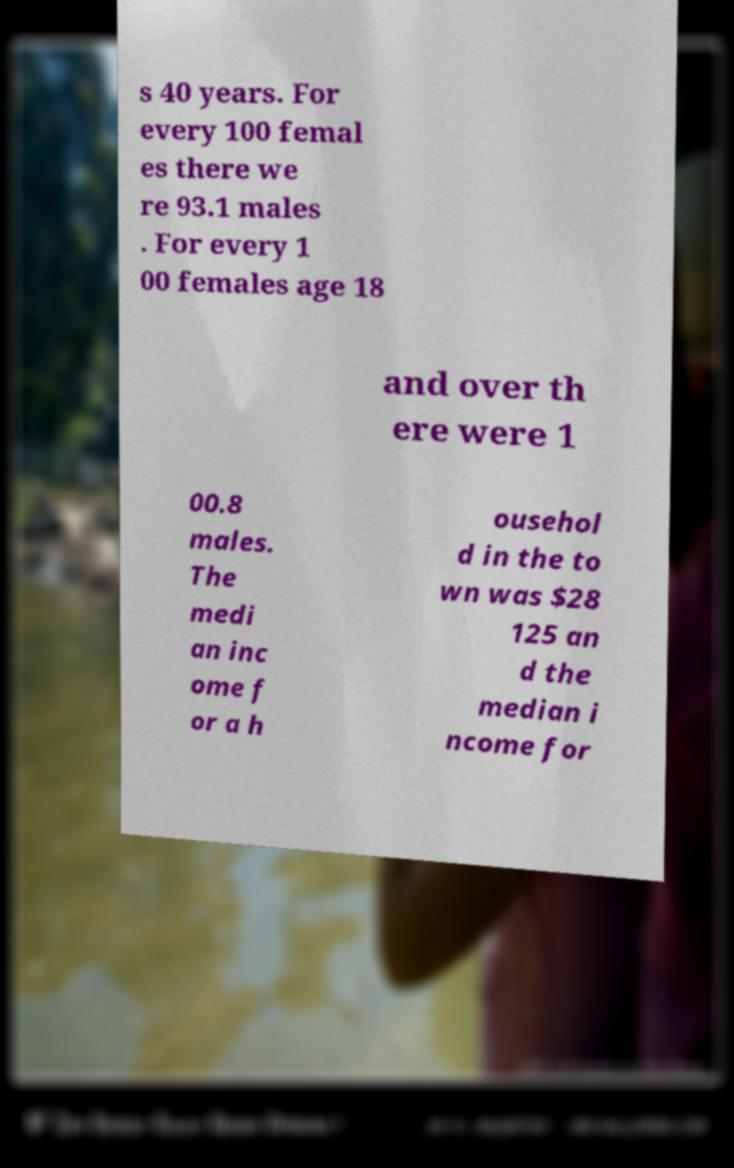Can you accurately transcribe the text from the provided image for me? s 40 years. For every 100 femal es there we re 93.1 males . For every 1 00 females age 18 and over th ere were 1 00.8 males. The medi an inc ome f or a h ousehol d in the to wn was $28 125 an d the median i ncome for 